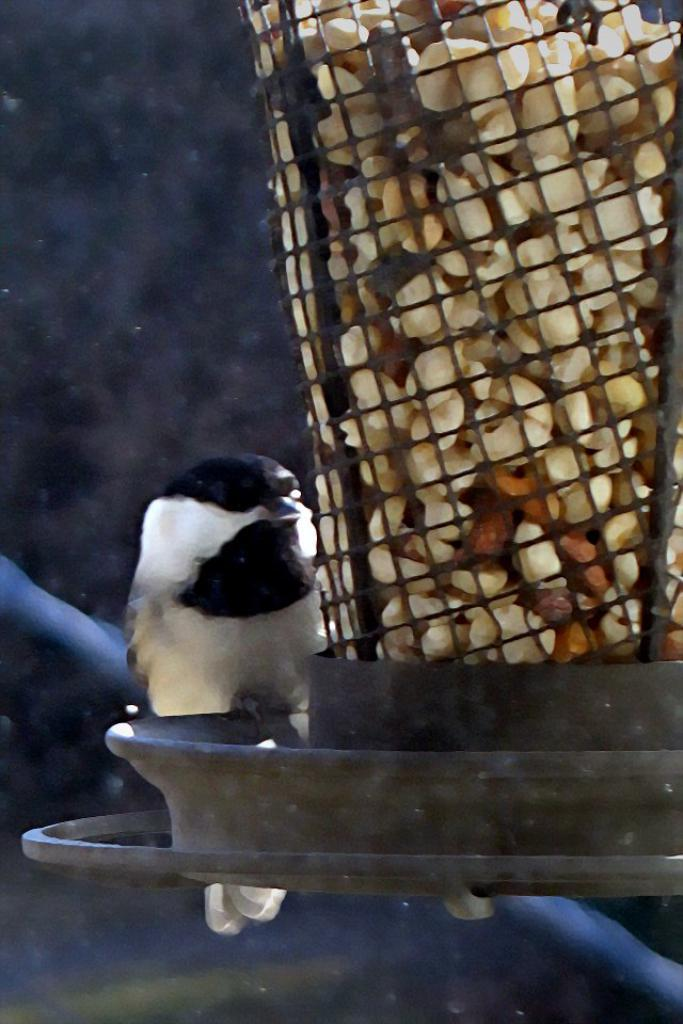What type of animal is present in the image? There is a bird in the image. Can you describe the bird's location in relation to any other objects in the image? The bird is beside a bird feeder. What time does the clock in the image show? There is no clock present in the image. What type of surprise can be seen in the image? There is no surprise present in the image. 